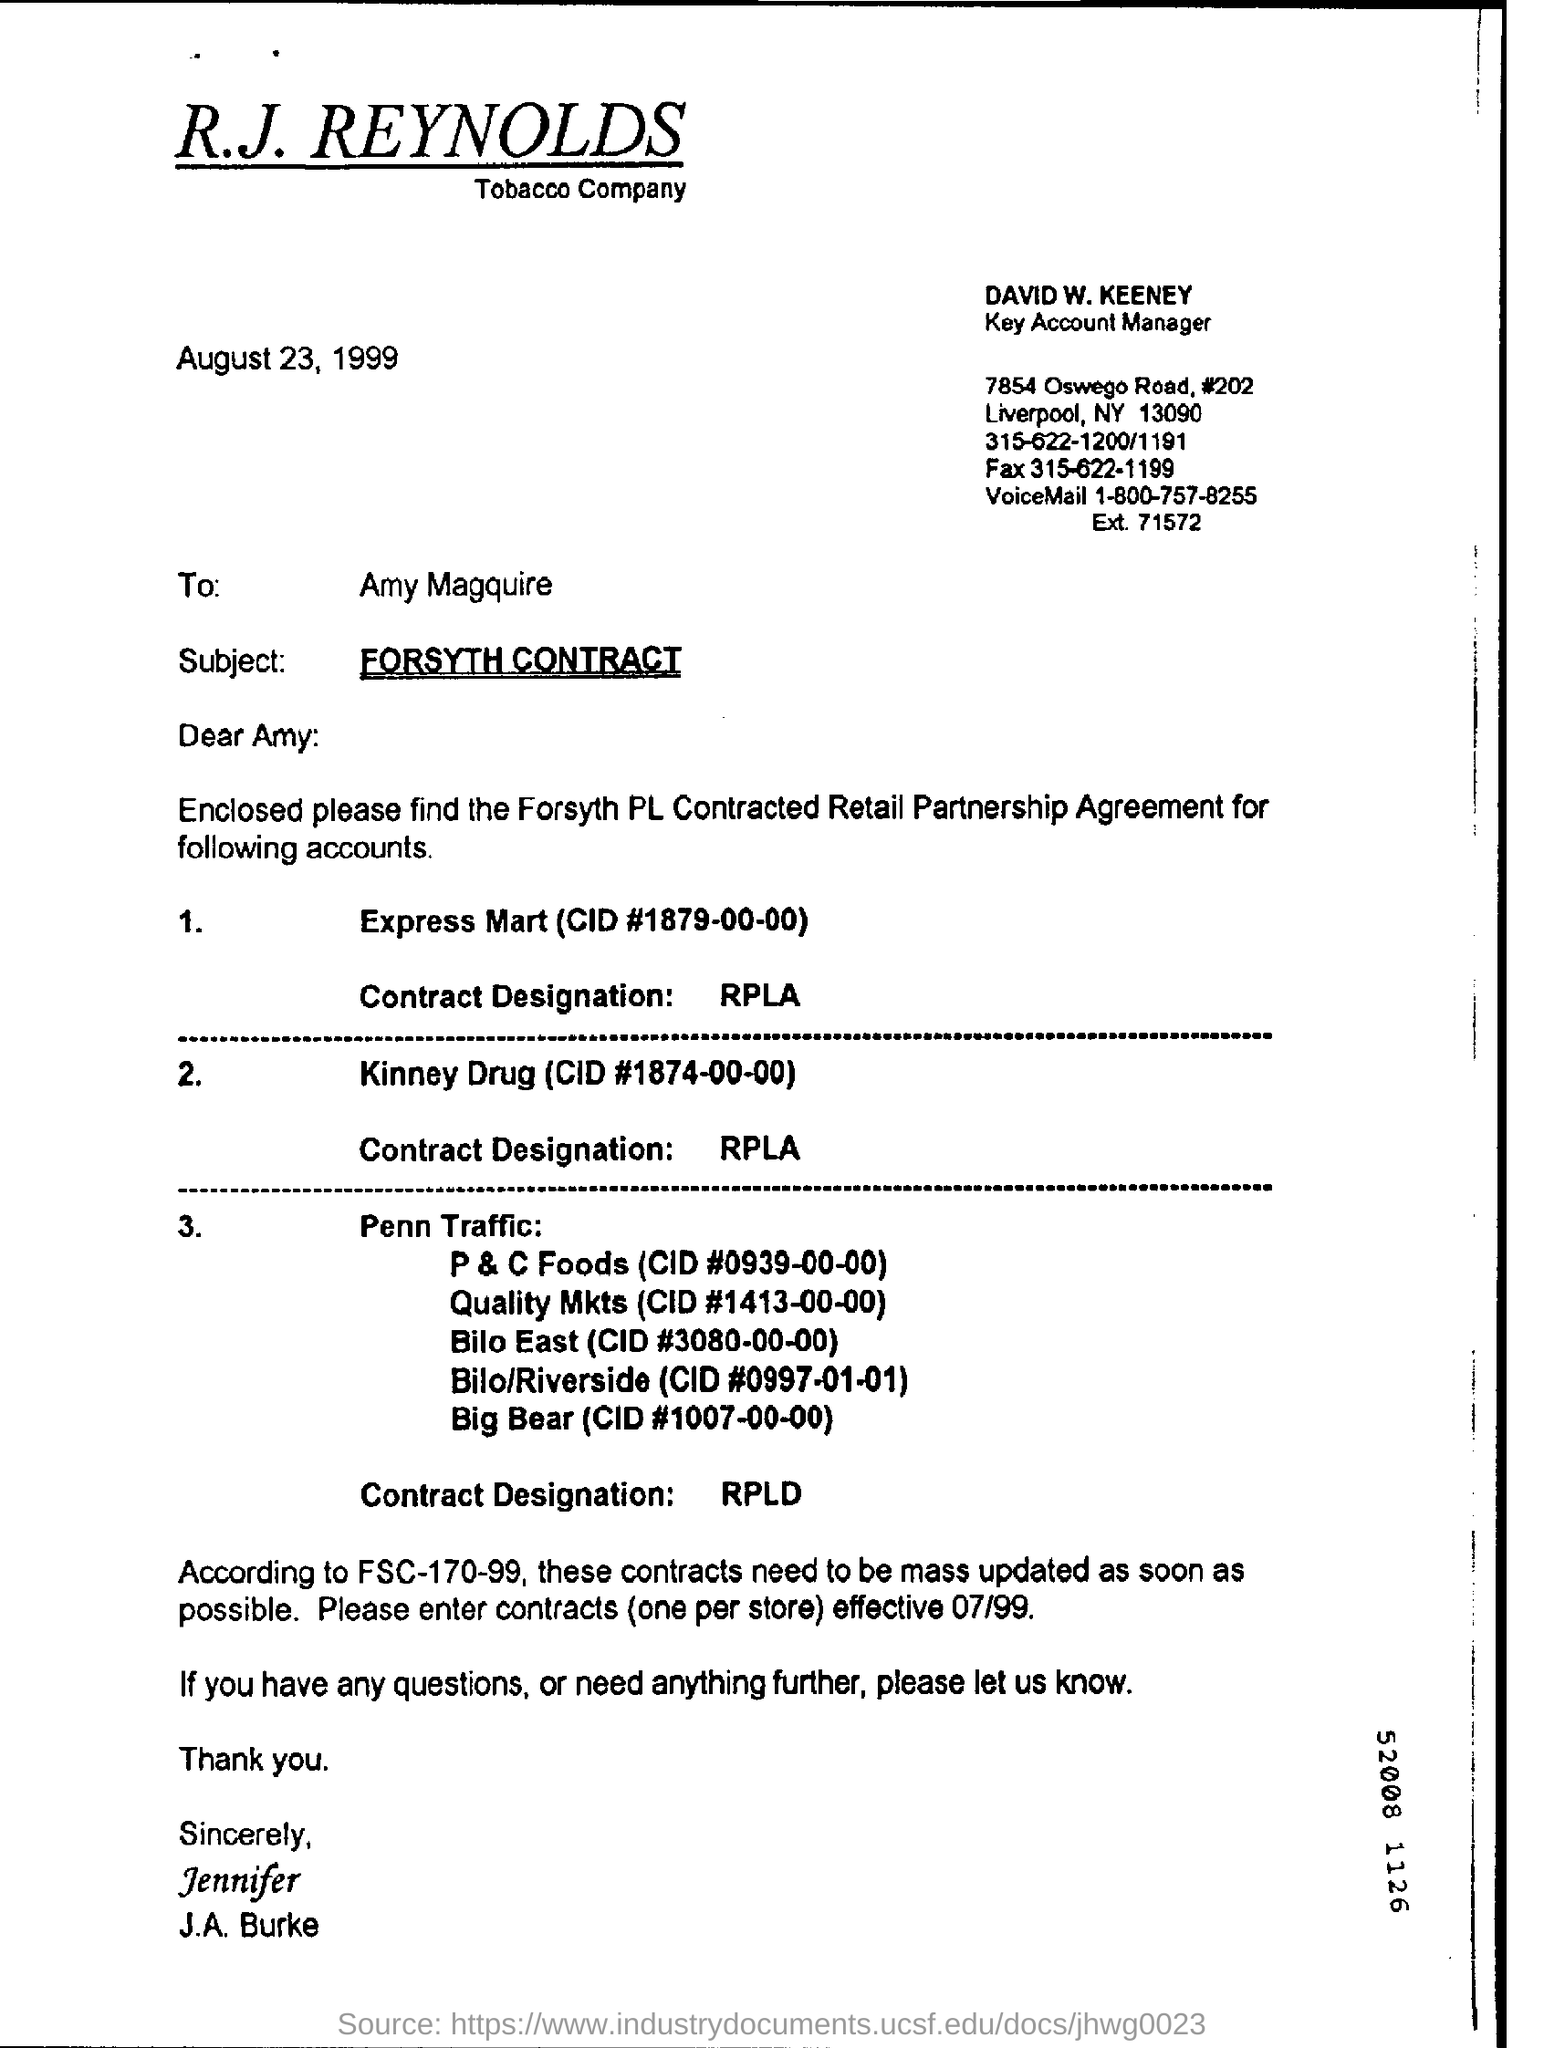Who is the key account Manager?
Offer a terse response. DAVID W. KEENEY. What is the subject of the letter?
Your answer should be very brief. FORSYTH CONTRACT. What is the contract designation for the Express Mart?
Ensure brevity in your answer.  RPLA. When is the letter dated on?
Offer a very short reply. August 23, 1999. 